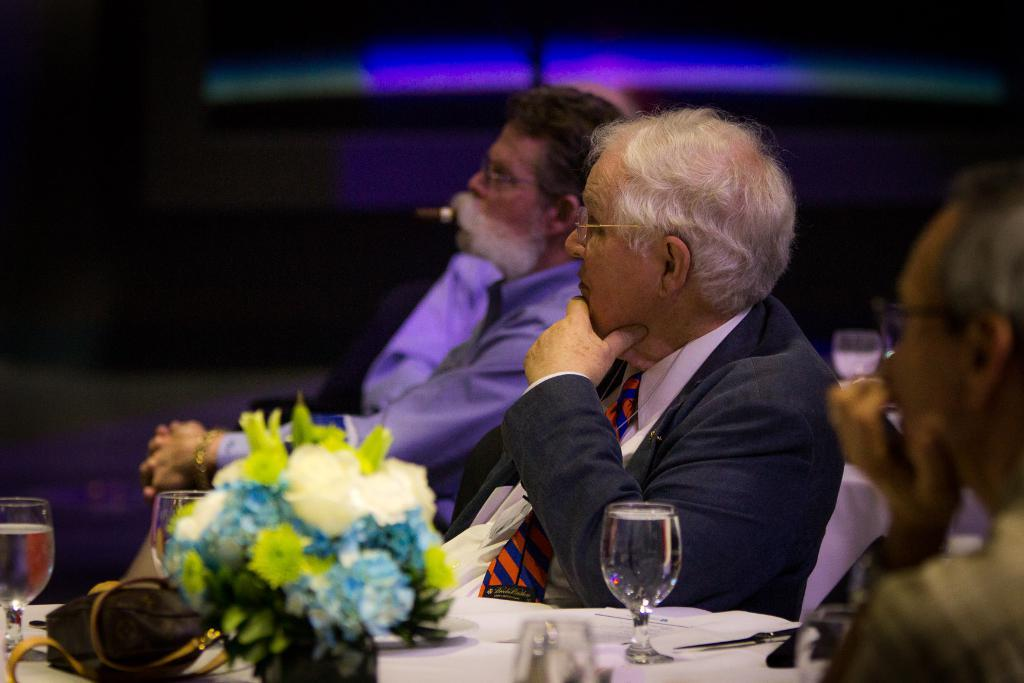How many people are in the image? There is a group of people in the image. What are the people doing in the image? The people are sitting on chairs. What objects are in front of the people? There are tables in front of the people. What items can be seen on the tables? Glasses, a flower bouquet, and a bag are on the tables. What is the lighting condition in the image? The background of the image is dark. What type of curtain is hanging from the ceiling in the image? There is no curtain present in the image. How many toads are sitting on the chairs with the people in the image? There are no toads present in the image; only people are sitting on the chairs. 